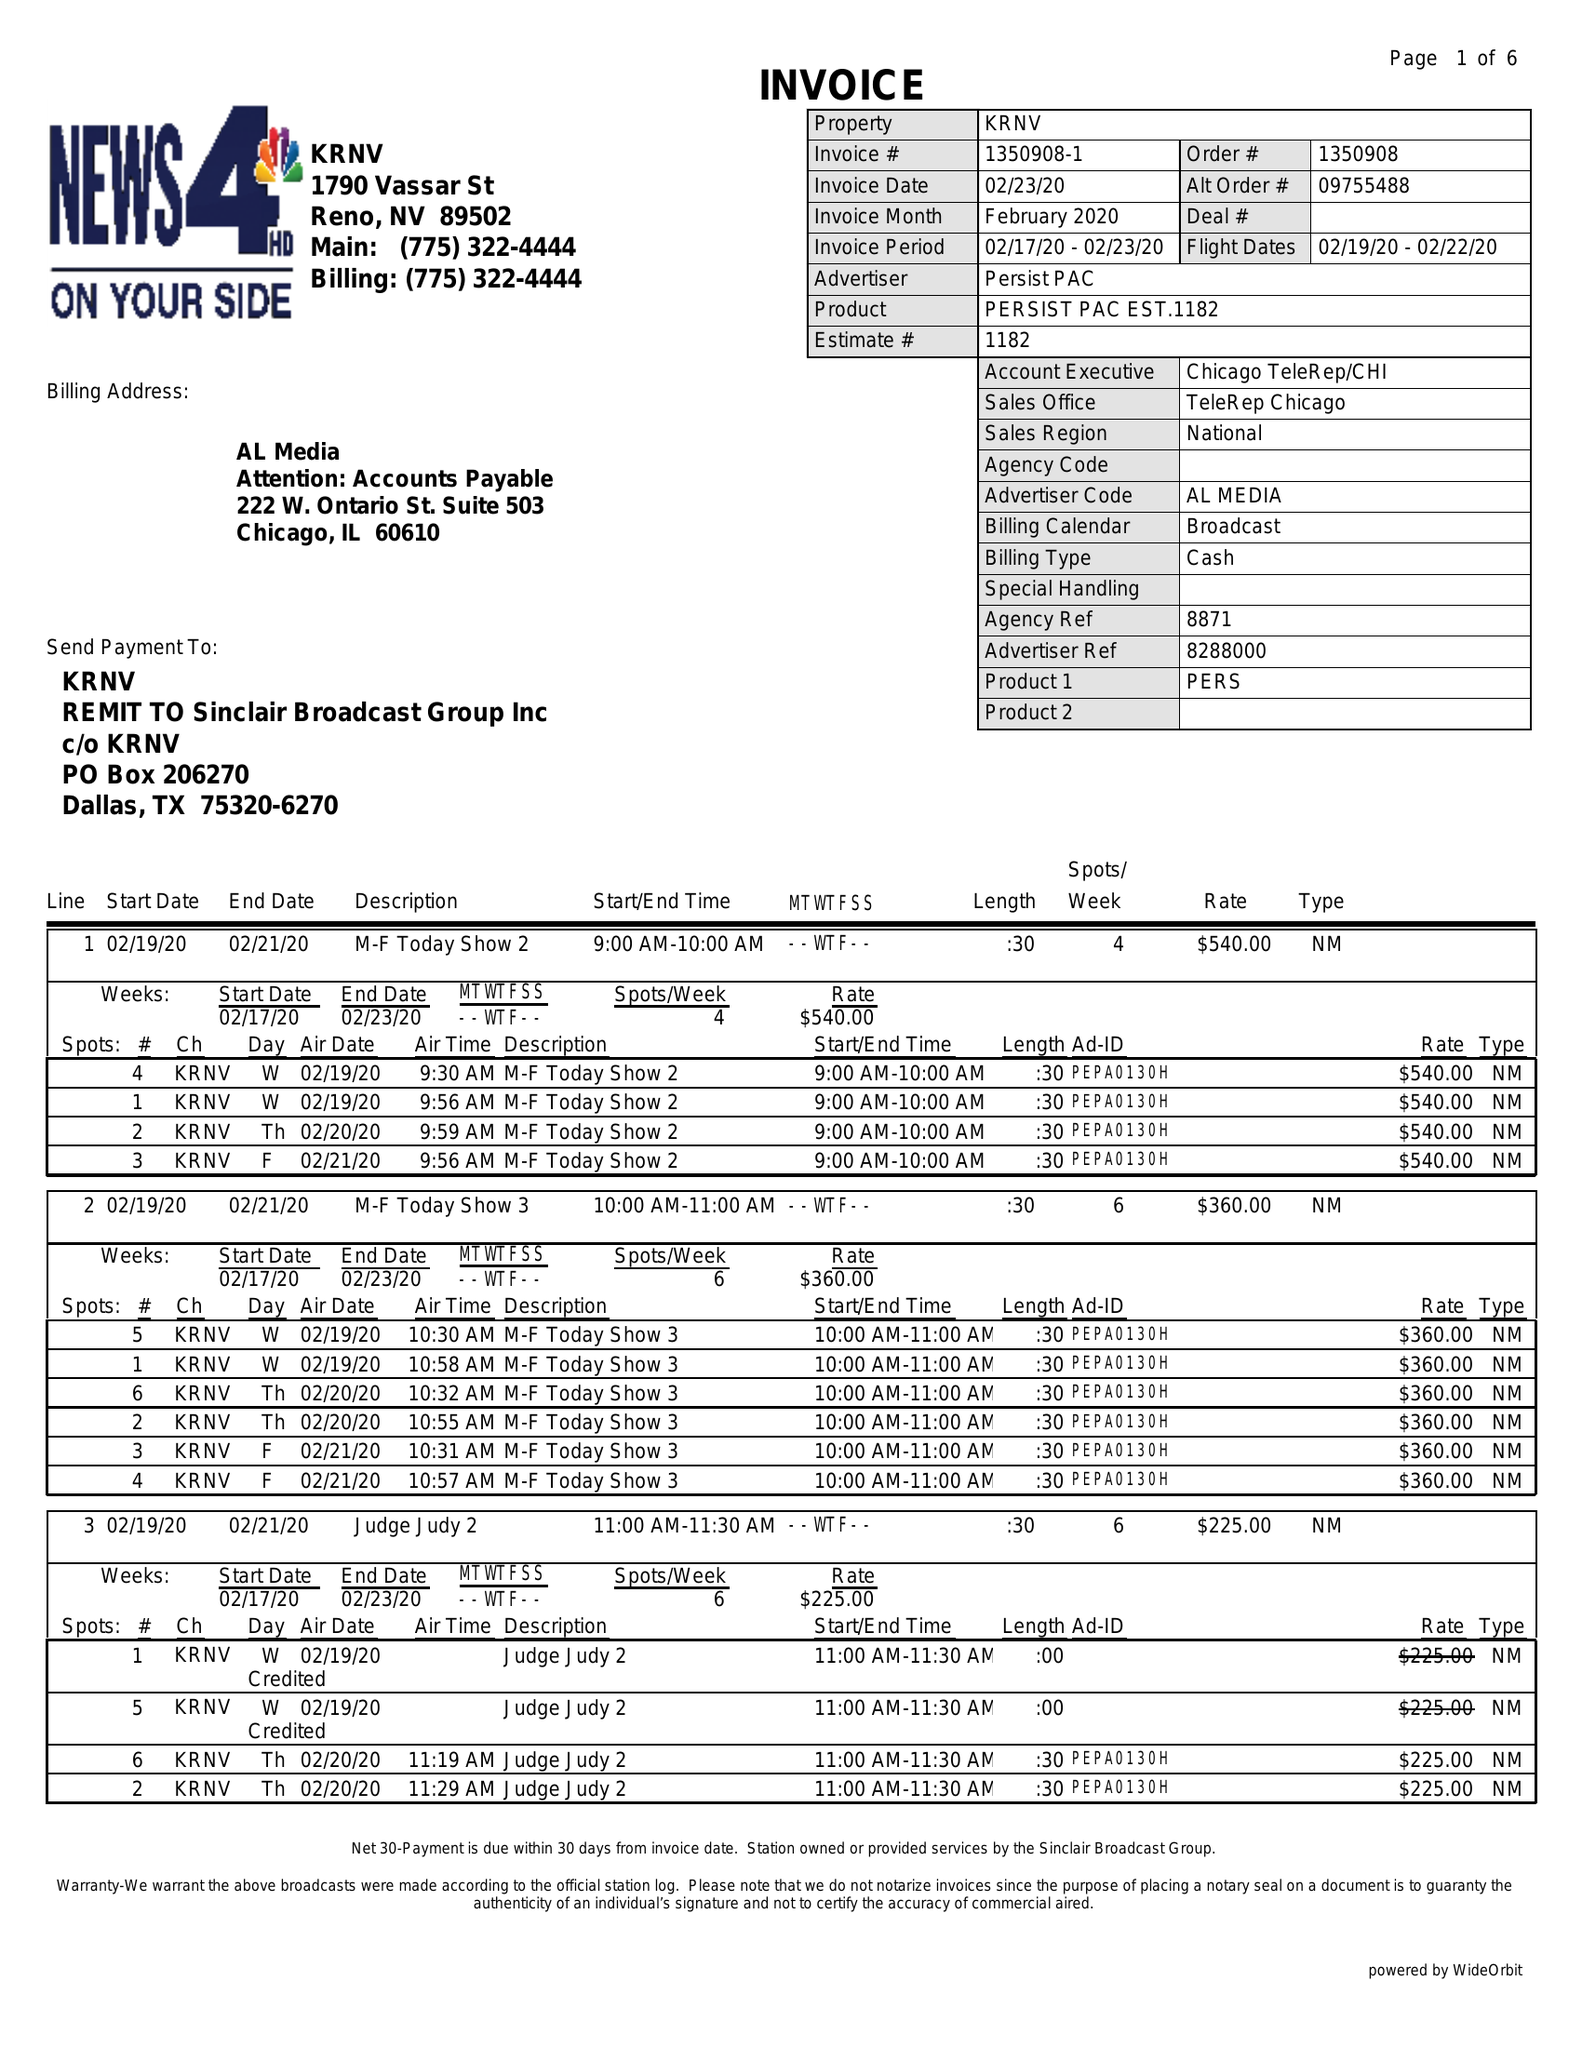What is the value for the contract_num?
Answer the question using a single word or phrase. 1350908 